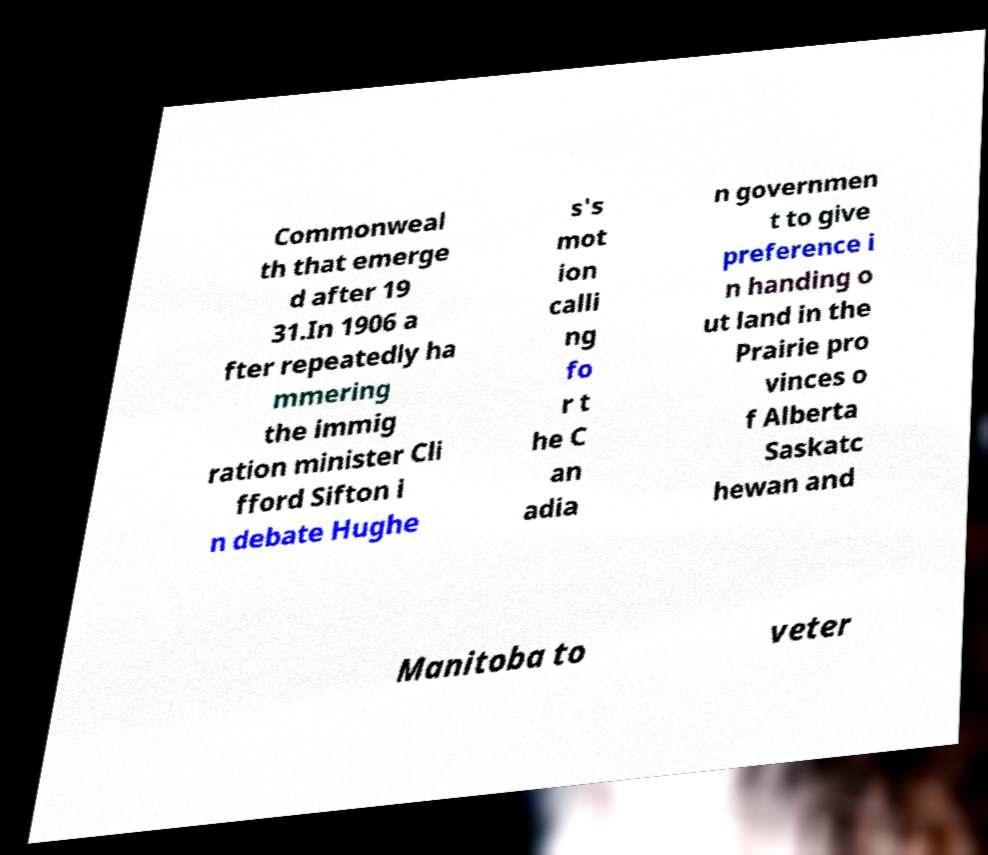I need the written content from this picture converted into text. Can you do that? Commonweal th that emerge d after 19 31.In 1906 a fter repeatedly ha mmering the immig ration minister Cli fford Sifton i n debate Hughe s's mot ion calli ng fo r t he C an adia n governmen t to give preference i n handing o ut land in the Prairie pro vinces o f Alberta Saskatc hewan and Manitoba to veter 